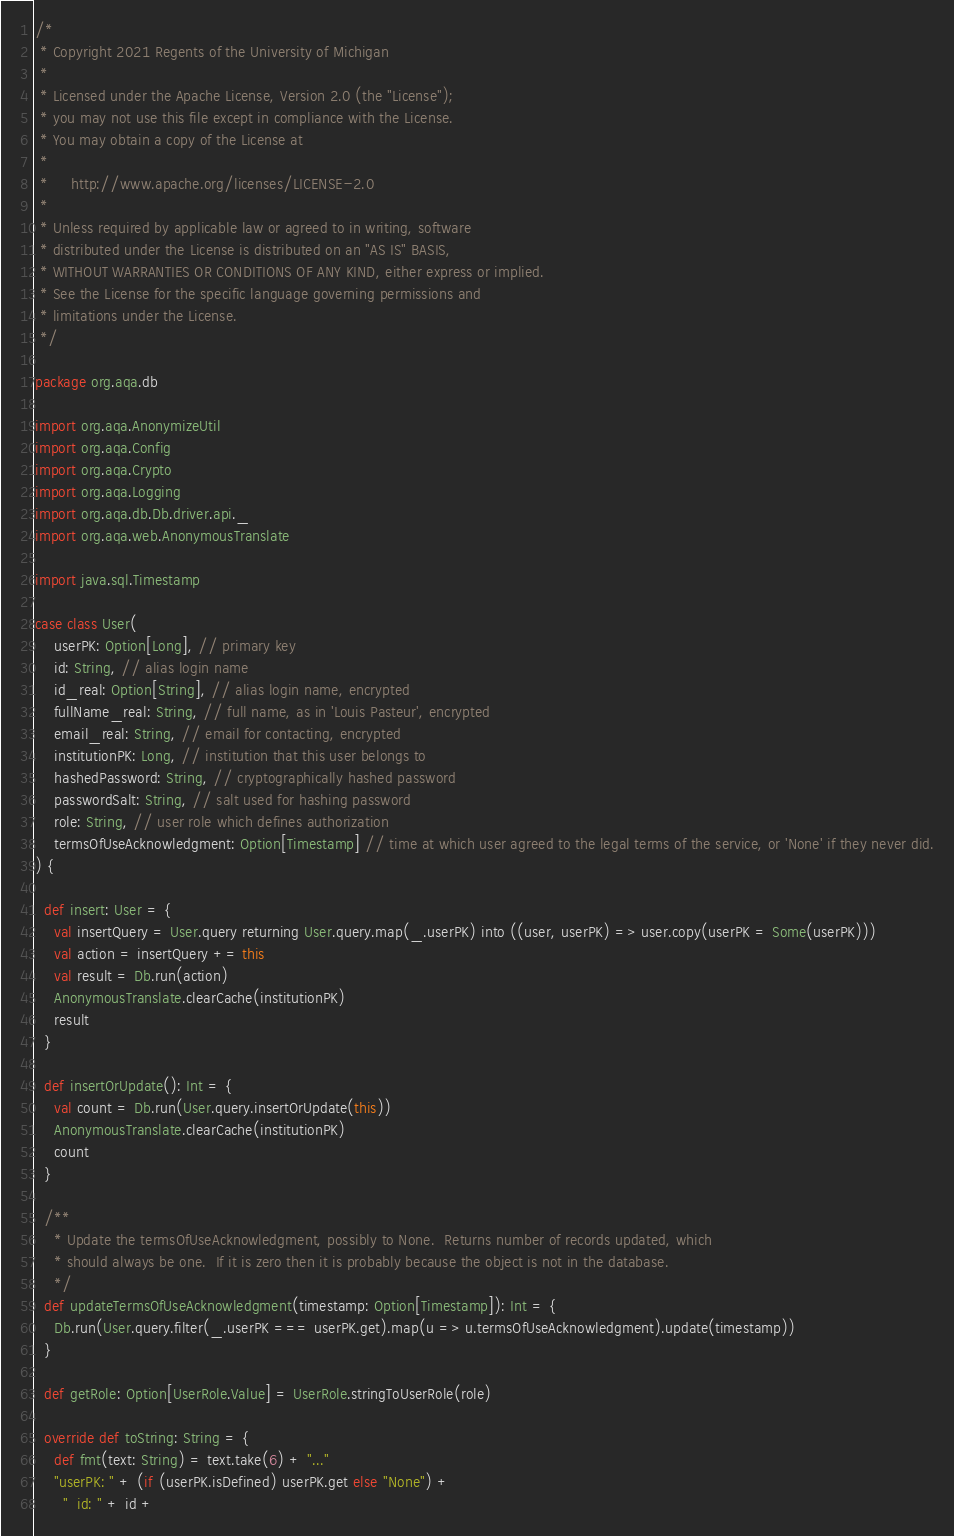Convert code to text. <code><loc_0><loc_0><loc_500><loc_500><_Scala_>/*
 * Copyright 2021 Regents of the University of Michigan
 *
 * Licensed under the Apache License, Version 2.0 (the "License");
 * you may not use this file except in compliance with the License.
 * You may obtain a copy of the License at
 *
 *     http://www.apache.org/licenses/LICENSE-2.0
 *
 * Unless required by applicable law or agreed to in writing, software
 * distributed under the License is distributed on an "AS IS" BASIS,
 * WITHOUT WARRANTIES OR CONDITIONS OF ANY KIND, either express or implied.
 * See the License for the specific language governing permissions and
 * limitations under the License.
 */

package org.aqa.db

import org.aqa.AnonymizeUtil
import org.aqa.Config
import org.aqa.Crypto
import org.aqa.Logging
import org.aqa.db.Db.driver.api._
import org.aqa.web.AnonymousTranslate

import java.sql.Timestamp

case class User(
    userPK: Option[Long], // primary key
    id: String, // alias login name
    id_real: Option[String], // alias login name, encrypted
    fullName_real: String, // full name, as in 'Louis Pasteur', encrypted
    email_real: String, // email for contacting, encrypted
    institutionPK: Long, // institution that this user belongs to
    hashedPassword: String, // cryptographically hashed password
    passwordSalt: String, // salt used for hashing password
    role: String, // user role which defines authorization
    termsOfUseAcknowledgment: Option[Timestamp] // time at which user agreed to the legal terms of the service, or 'None' if they never did.
) {

  def insert: User = {
    val insertQuery = User.query returning User.query.map(_.userPK) into ((user, userPK) => user.copy(userPK = Some(userPK)))
    val action = insertQuery += this
    val result = Db.run(action)
    AnonymousTranslate.clearCache(institutionPK)
    result
  }

  def insertOrUpdate(): Int = {
    val count = Db.run(User.query.insertOrUpdate(this))
    AnonymousTranslate.clearCache(institutionPK)
    count
  }

  /**
    * Update the termsOfUseAcknowledgment, possibly to None.  Returns number of records updated, which
    * should always be one.  If it is zero then it is probably because the object is not in the database.
    */
  def updateTermsOfUseAcknowledgment(timestamp: Option[Timestamp]): Int = {
    Db.run(User.query.filter(_.userPK === userPK.get).map(u => u.termsOfUseAcknowledgment).update(timestamp))
  }

  def getRole: Option[UserRole.Value] = UserRole.stringToUserRole(role)

  override def toString: String = {
    def fmt(text: String) = text.take(6) + "..."
    "userPK: " + (if (userPK.isDefined) userPK.get else "None") +
      "  id: " + id +</code> 